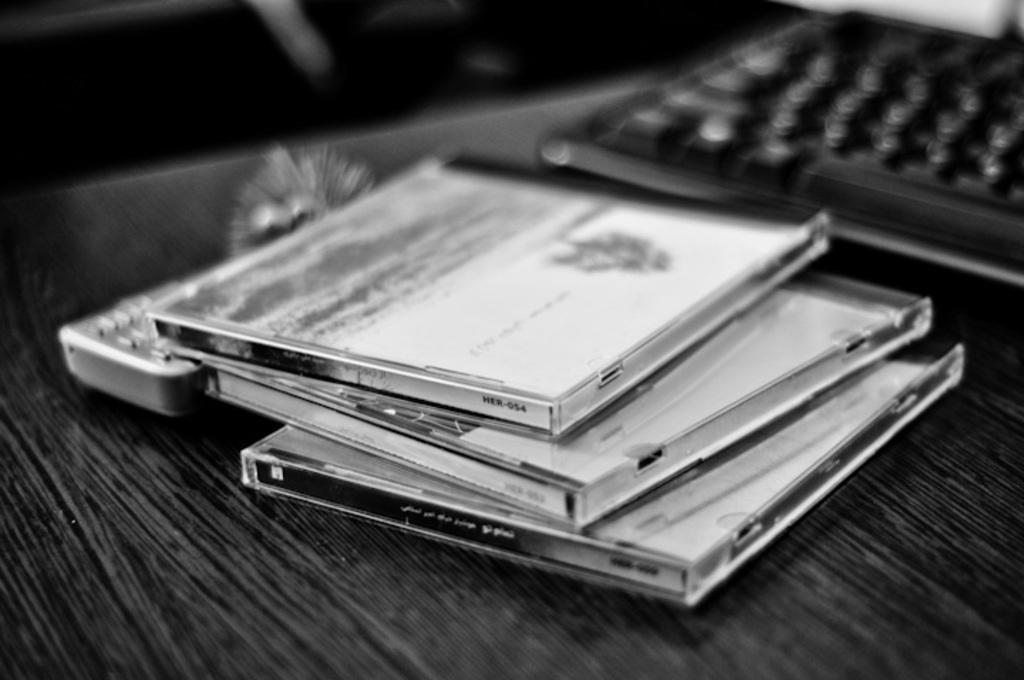What letters and numbers are written on the spine of the cd on top of the pile?
Offer a very short reply. Unanswerable. 